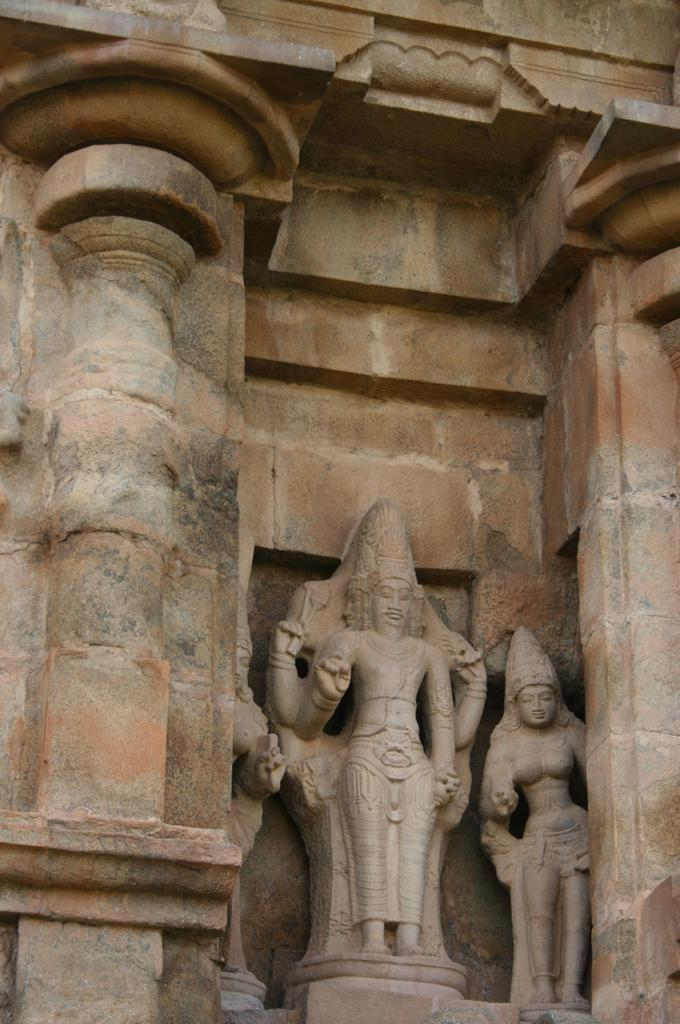What type of objects can be seen in the image? There are statues in the image. What architectural feature is present in the image? There is a wall in the image. How many children are playing near the statues in the image? There are no children present in the image; it only features statues and a wall. 